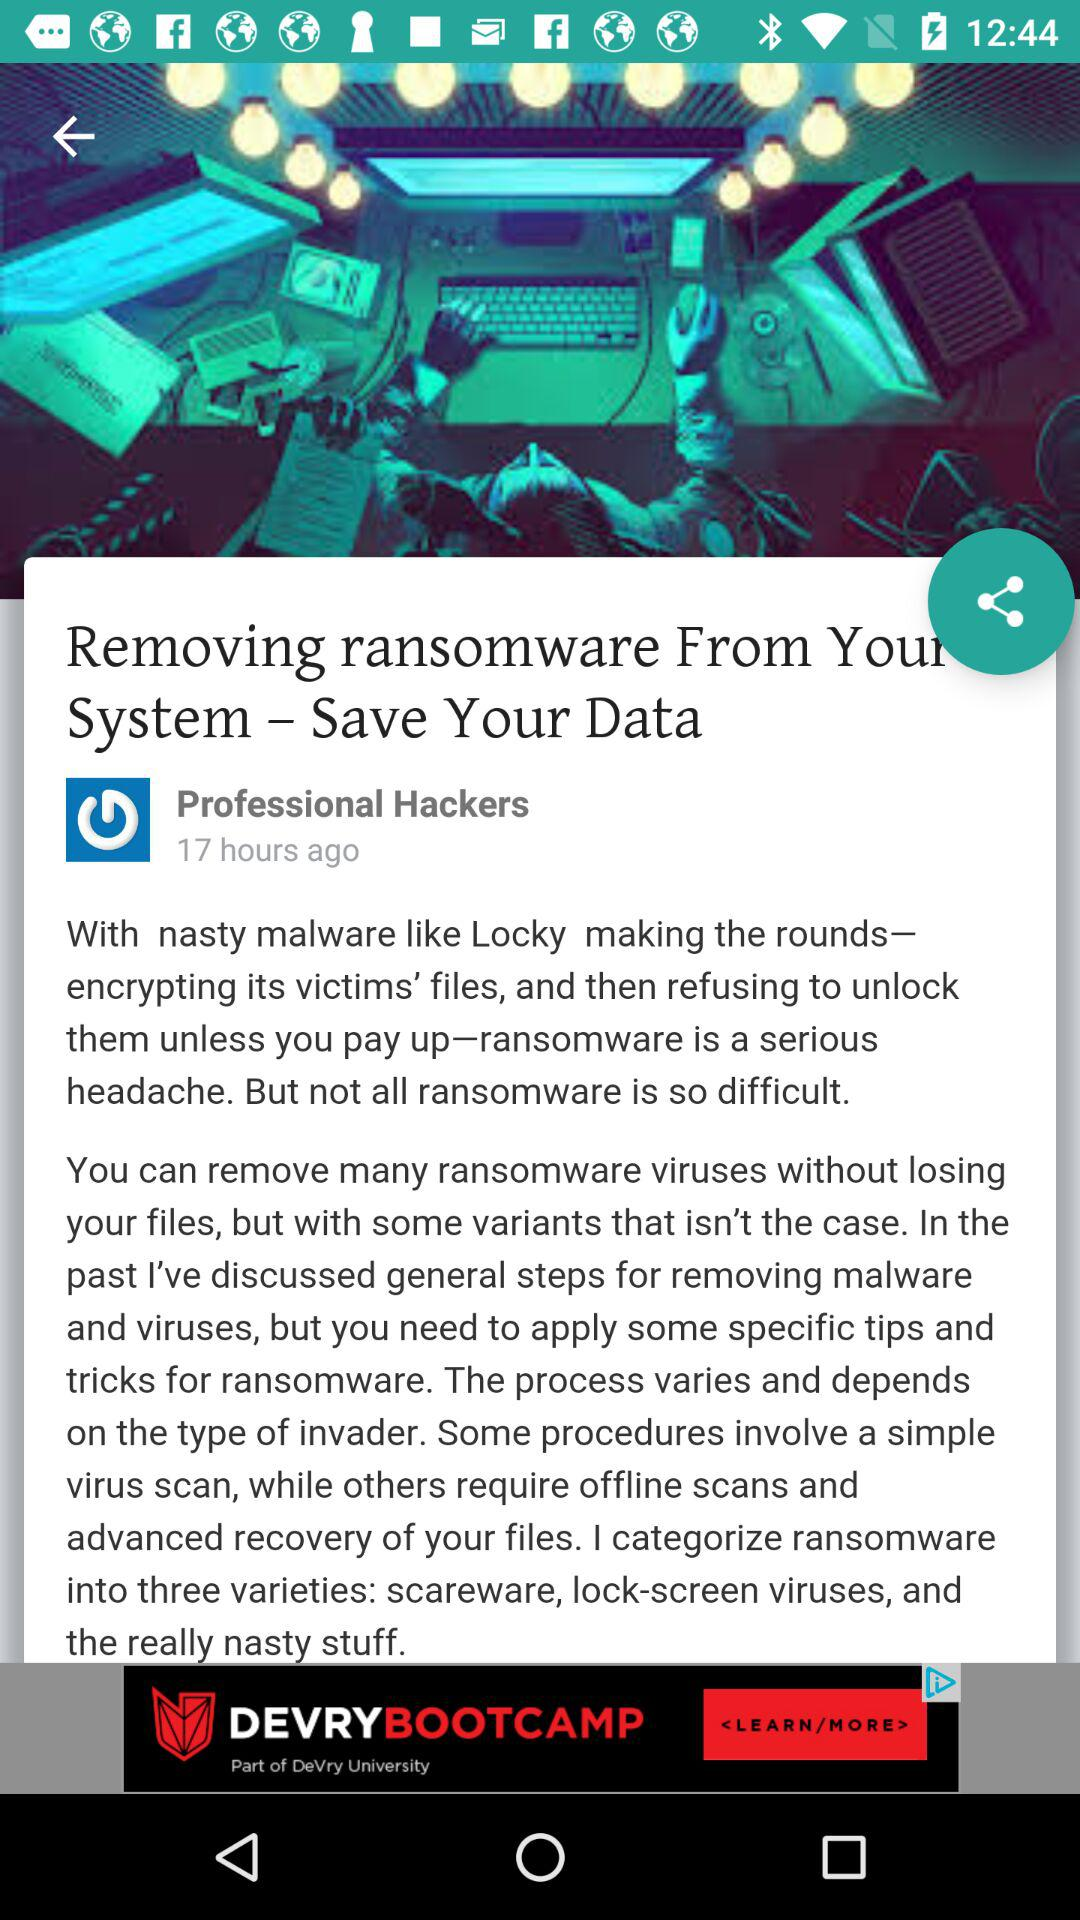How many hours ago was this article posted? The article was posted 17 hours ago. 